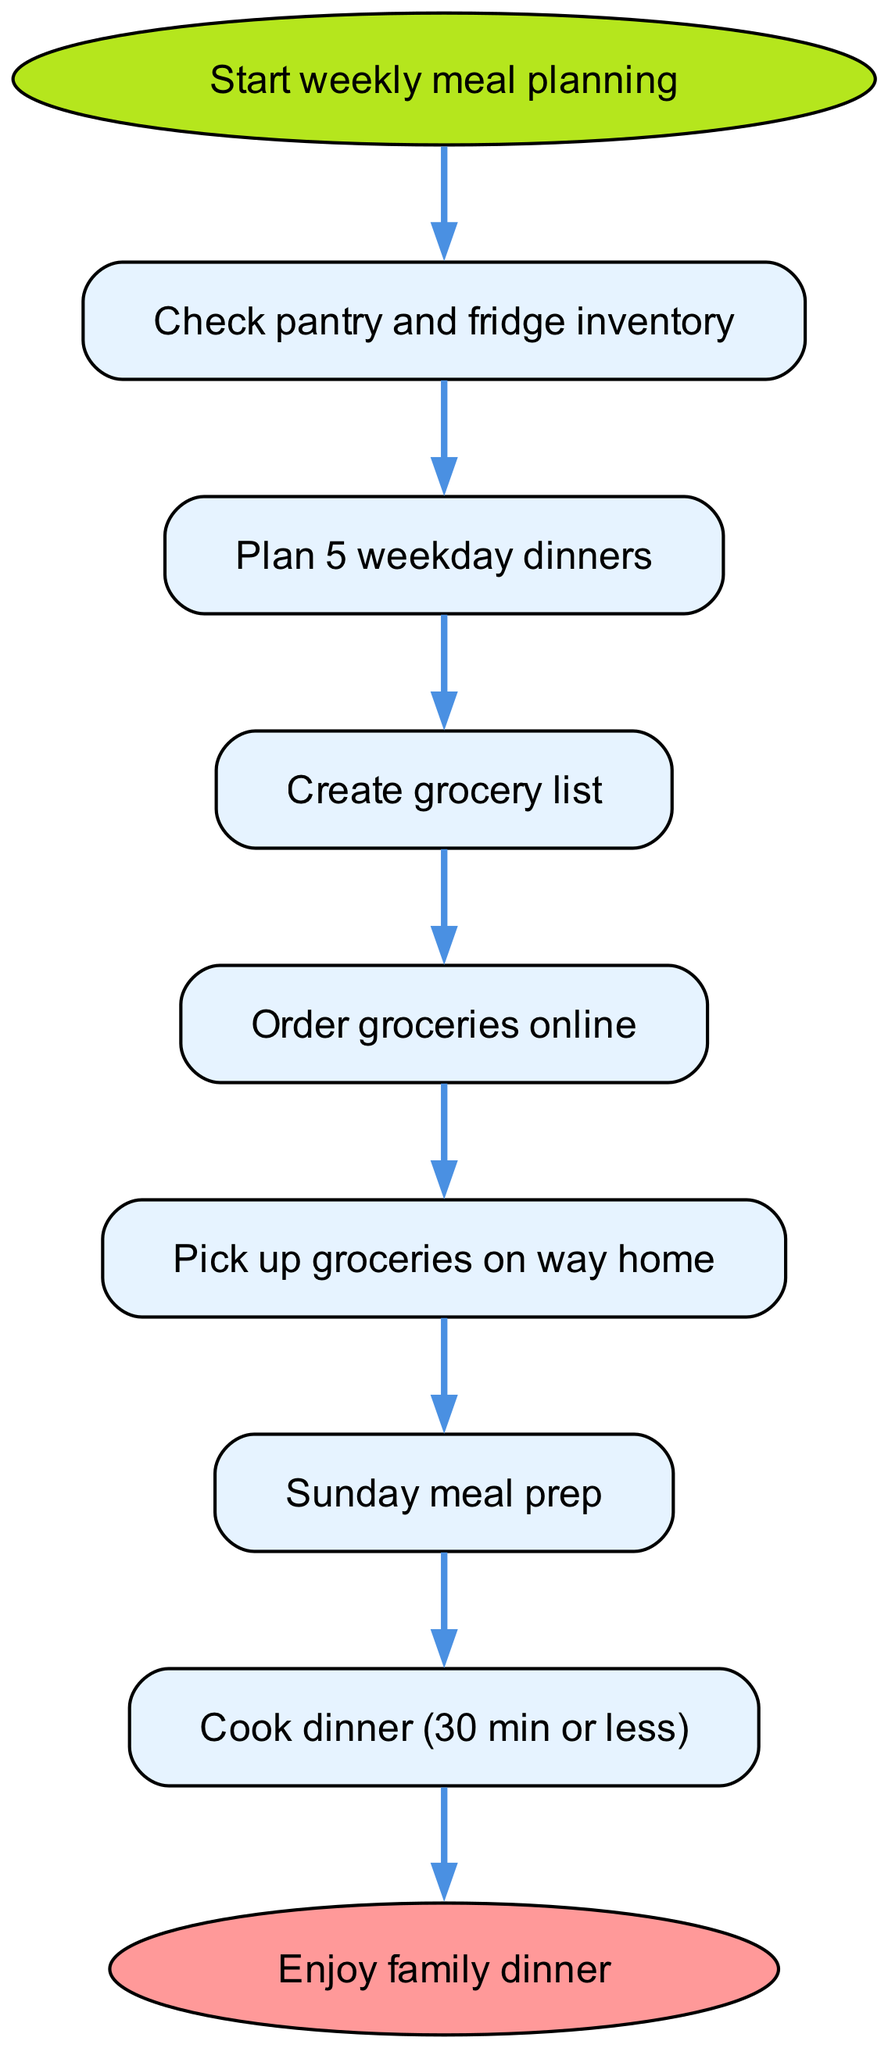What is the first step in the workflow? The first node after the start is "Check pantry and fridge inventory", indicating that the process begins with checking what ingredients are available at home.
Answer: Check pantry and fridge inventory How many nodes are in the diagram? By counting all unique nodes from the data provided, we can identify that there are 8 distinct nodes along the flow of the diagram.
Answer: 8 What is the last step in the meal prep process? The final node before ending the flow is "Enjoy family dinner", meaning once all prior steps have been completed, the family can enjoy their meal together.
Answer: Enjoy family dinner In which step do you prepare meals? The step labeled "Sunday meal prep" signifies the specific phase where meal preparations are made, suggesting this occurs in advance of the week.
Answer: Sunday meal prep What follows after creating a grocery list? The edge leading from "Create grocery list" goes directly to "Order groceries online", indicating that these two steps are sequential. Hence, after a grocery list is made, groceries are ordered online.
Answer: Order groceries online How many edges are there in the flowchart? Each connection between the nodes represents an edge, and by counting the connections listed, we find there are 7 edges that define the workflow.
Answer: 7 What is the relationship between planning meals and checking inventory? "Plan meals" is directly connected to "Check pantry and fridge inventory", showing that meal planning depends on the prior step of checking what is available.
Answer: Plan meals Which step comes after picking up groceries? Following the "Pick up groceries" step, the next node is "Sunday meal prep", suggesting that after groceries are picked up, meal prep takes place.
Answer: Sunday meal prep 